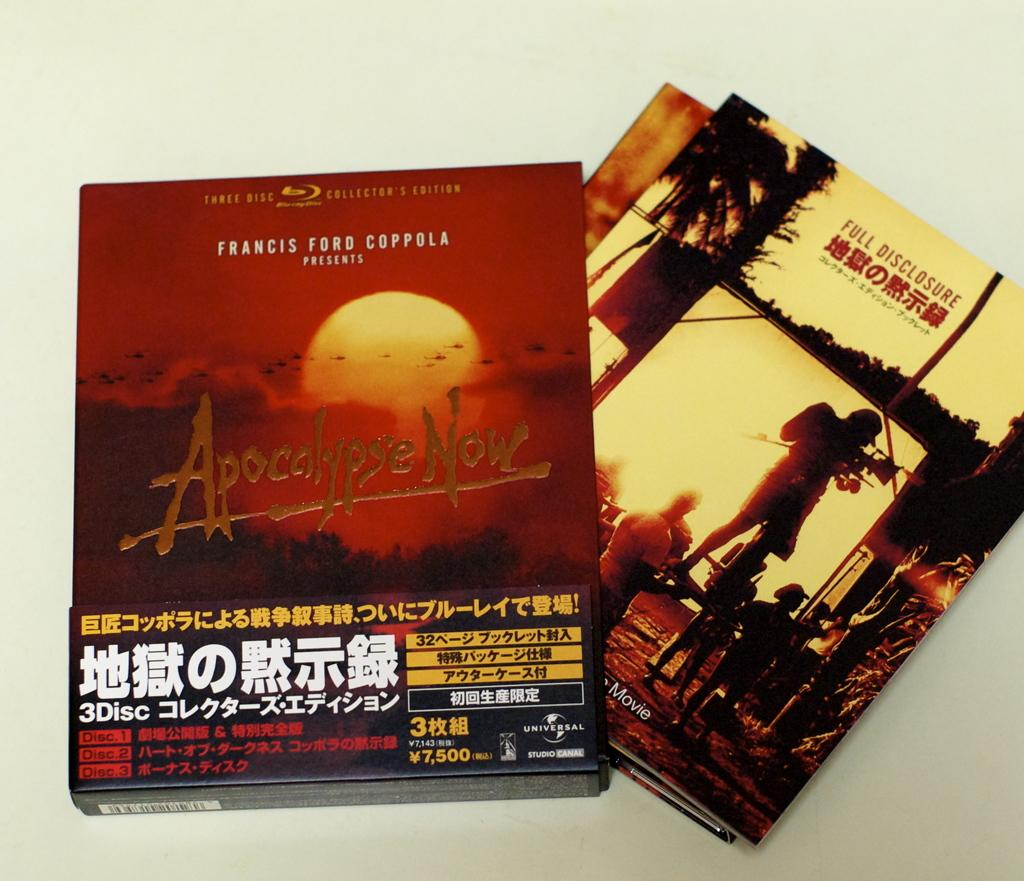<image>
Offer a succinct explanation of the picture presented. a box of magazines titled ' apocolypse now' on the cover 